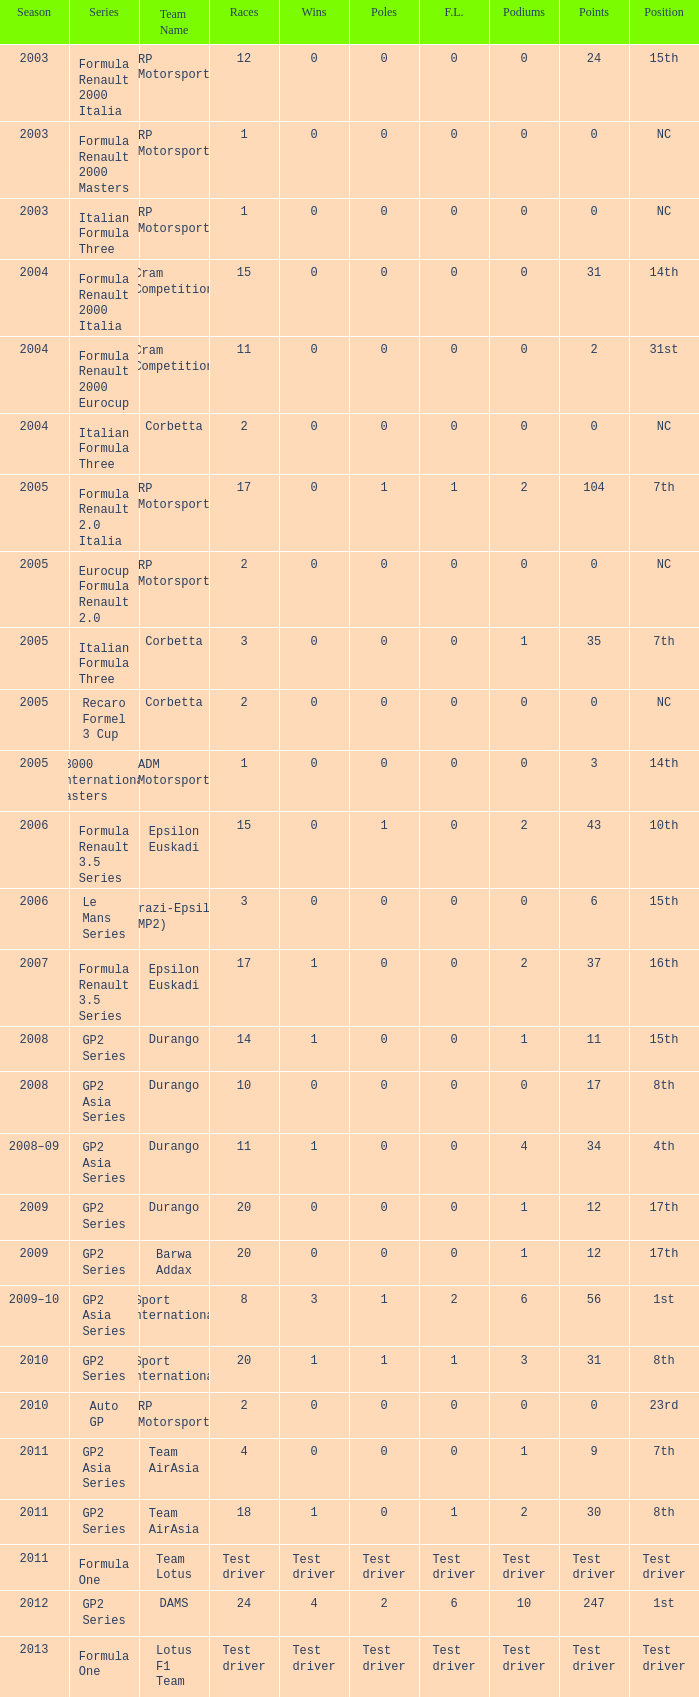What is the count of poles in four races? 0.0. 